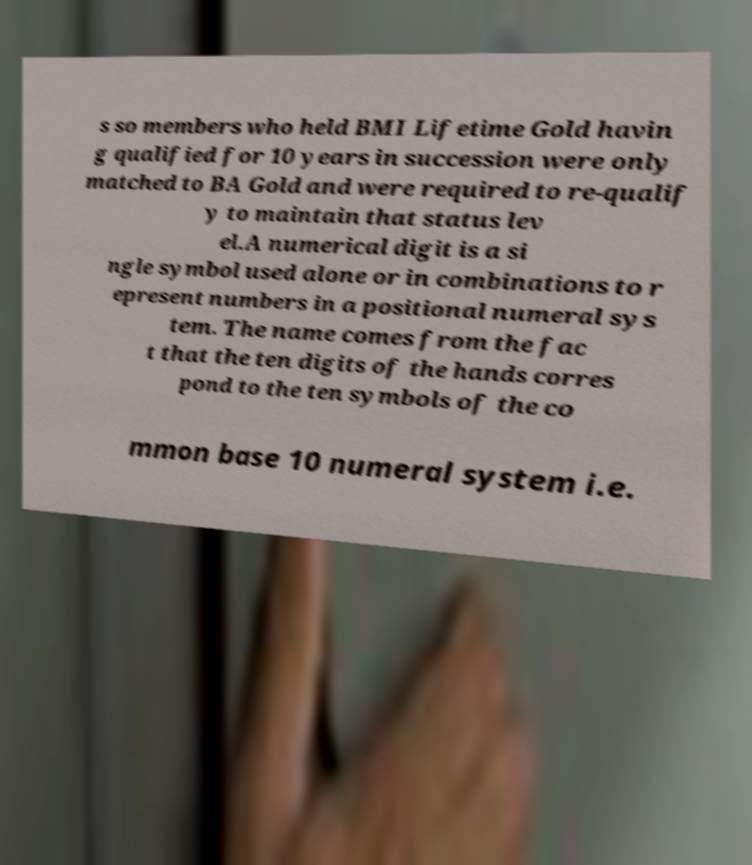Can you read and provide the text displayed in the image?This photo seems to have some interesting text. Can you extract and type it out for me? s so members who held BMI Lifetime Gold havin g qualified for 10 years in succession were only matched to BA Gold and were required to re-qualif y to maintain that status lev el.A numerical digit is a si ngle symbol used alone or in combinations to r epresent numbers in a positional numeral sys tem. The name comes from the fac t that the ten digits of the hands corres pond to the ten symbols of the co mmon base 10 numeral system i.e. 